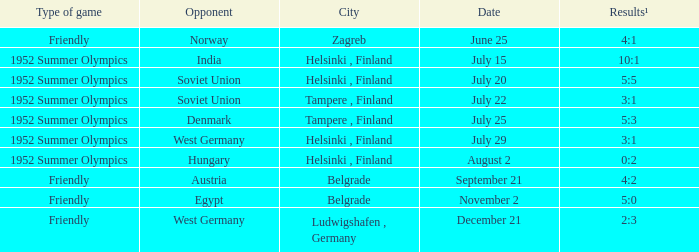What is the name of the City with December 21 as a Date? Ludwigshafen , Germany. 